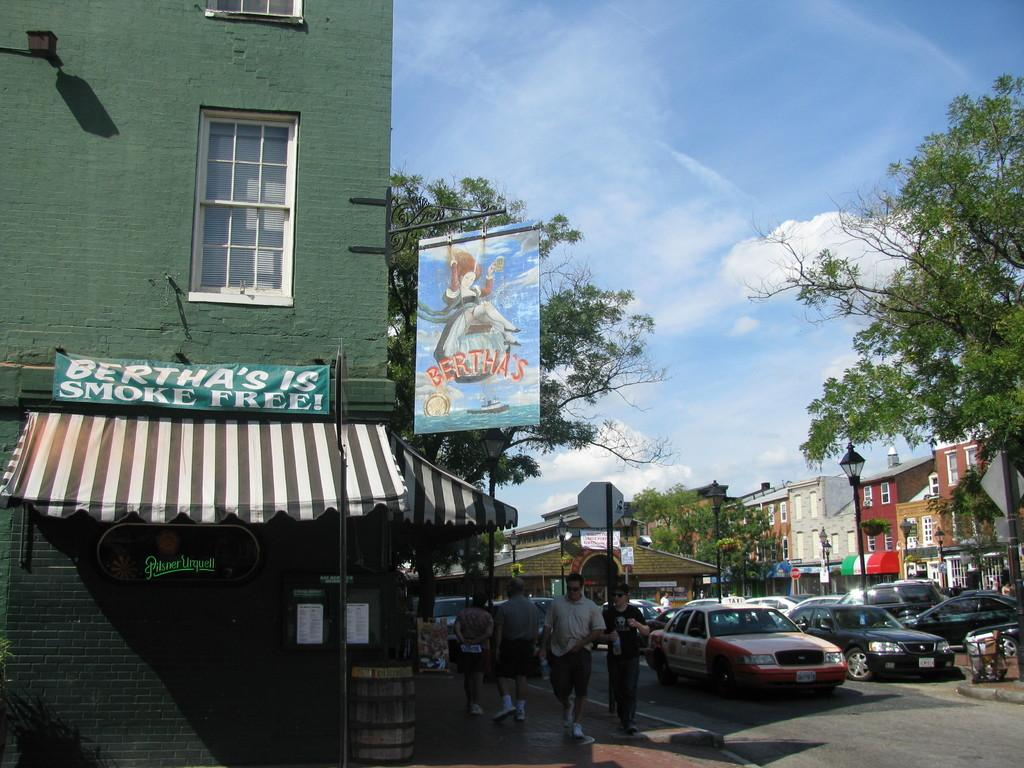Provide a one-sentence caption for the provided image. bertha's corner store claims to be smoke free. 